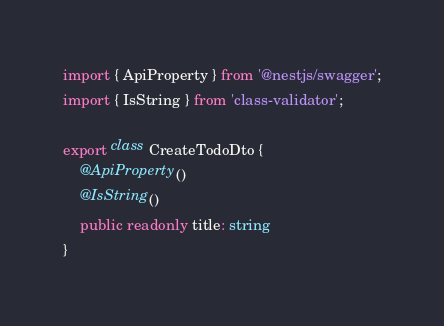<code> <loc_0><loc_0><loc_500><loc_500><_TypeScript_>import { ApiProperty } from '@nestjs/swagger';
import { IsString } from 'class-validator';

export class CreateTodoDto {
    @ApiProperty()
    @IsString()
    public readonly title: string
}
</code> 